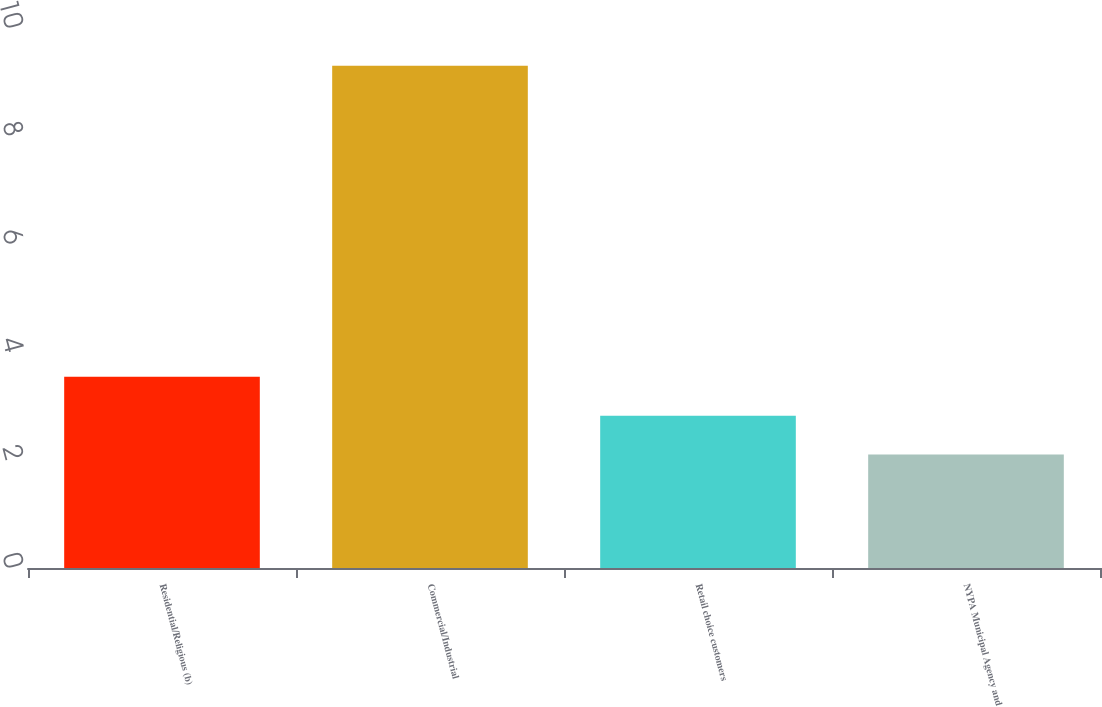Convert chart. <chart><loc_0><loc_0><loc_500><loc_500><bar_chart><fcel>Residential/Religious (b)<fcel>Commercial/Industrial<fcel>Retail choice customers<fcel>NYPA Municipal Agency and<nl><fcel>3.54<fcel>9.3<fcel>2.82<fcel>2.1<nl></chart> 